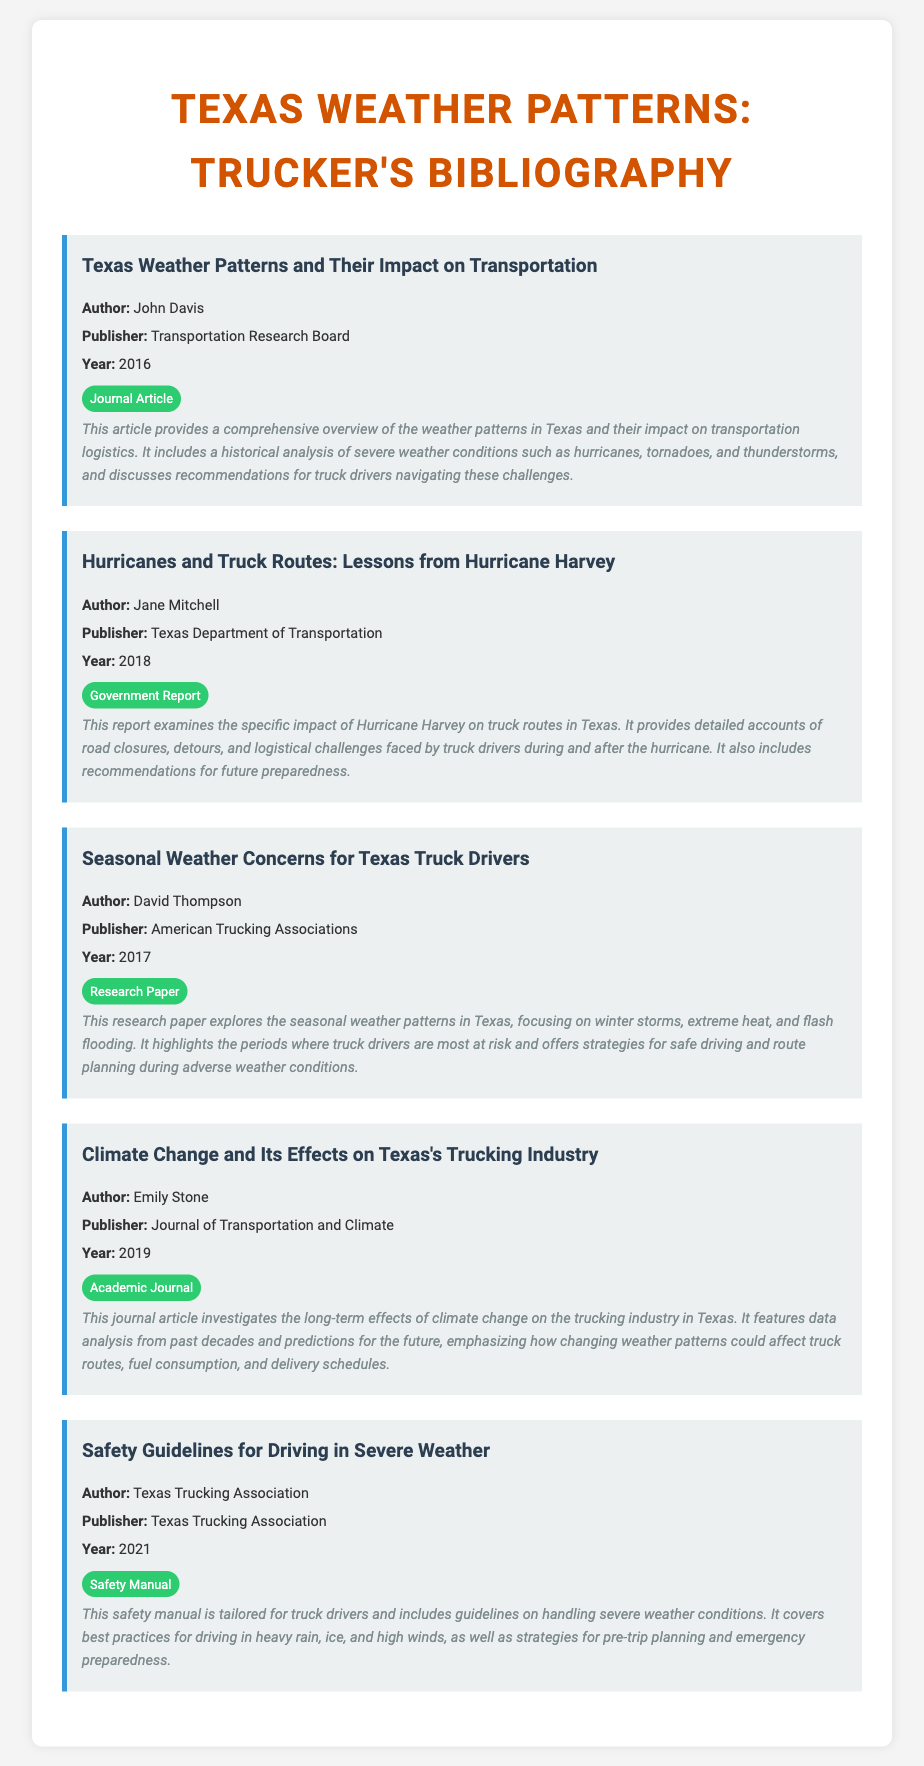What is the title of the first bibliography item? The title of the first bibliography item is provided in the document under the headings for each entry.
Answer: Texas Weather Patterns and Their Impact on Transportation Who is the author of the report on Hurricane Harvey? The author information is clearly mentioned in the bibliography item related to Hurricane Harvey.
Answer: Jane Mitchell In what year was the safety manual published? The publication year for each item is indicated directly beneath the author's name for quick reference.
Answer: 2021 How many bibliography items discuss seasonal weather concerns for truck drivers? The total number of items can be directly counted from the document; one item discusses seasonal weather concerns.
Answer: One What type of document is "Climate Change and Its Effects on Texas's Trucking Industry"? Each item includes a type badge indicating what kind of document it is.
Answer: Academic Journal What is one recommendation included in "Safety Guidelines for Driving in Severe Weather"? Recommendations are generally summarized in the descriptions of the bibliography items.
Answer: Best practices for driving in heavy rain What organization published the report on Hurricane Harvey? The publisher of each bibliography item is stated clearly within the document structure.
Answer: Texas Department of Transportation What does David Thompson's paper focus on? The research focus areas are summarized in the descriptions provided in the document.
Answer: Seasonal weather patterns 